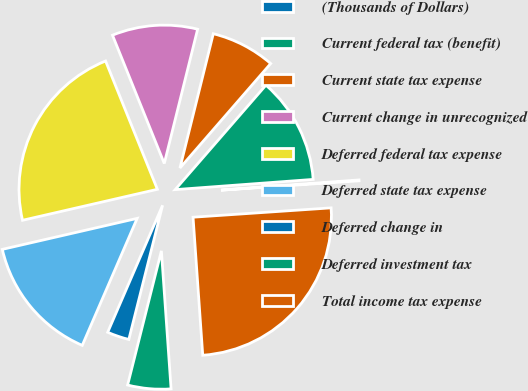Convert chart. <chart><loc_0><loc_0><loc_500><loc_500><pie_chart><fcel>(Thousands of Dollars)<fcel>Current federal tax (benefit)<fcel>Current state tax expense<fcel>Current change in unrecognized<fcel>Deferred federal tax expense<fcel>Deferred state tax expense<fcel>Deferred change in<fcel>Deferred investment tax<fcel>Total income tax expense<nl><fcel>0.1%<fcel>12.44%<fcel>7.51%<fcel>9.98%<fcel>22.49%<fcel>14.91%<fcel>2.57%<fcel>5.04%<fcel>24.96%<nl></chart> 